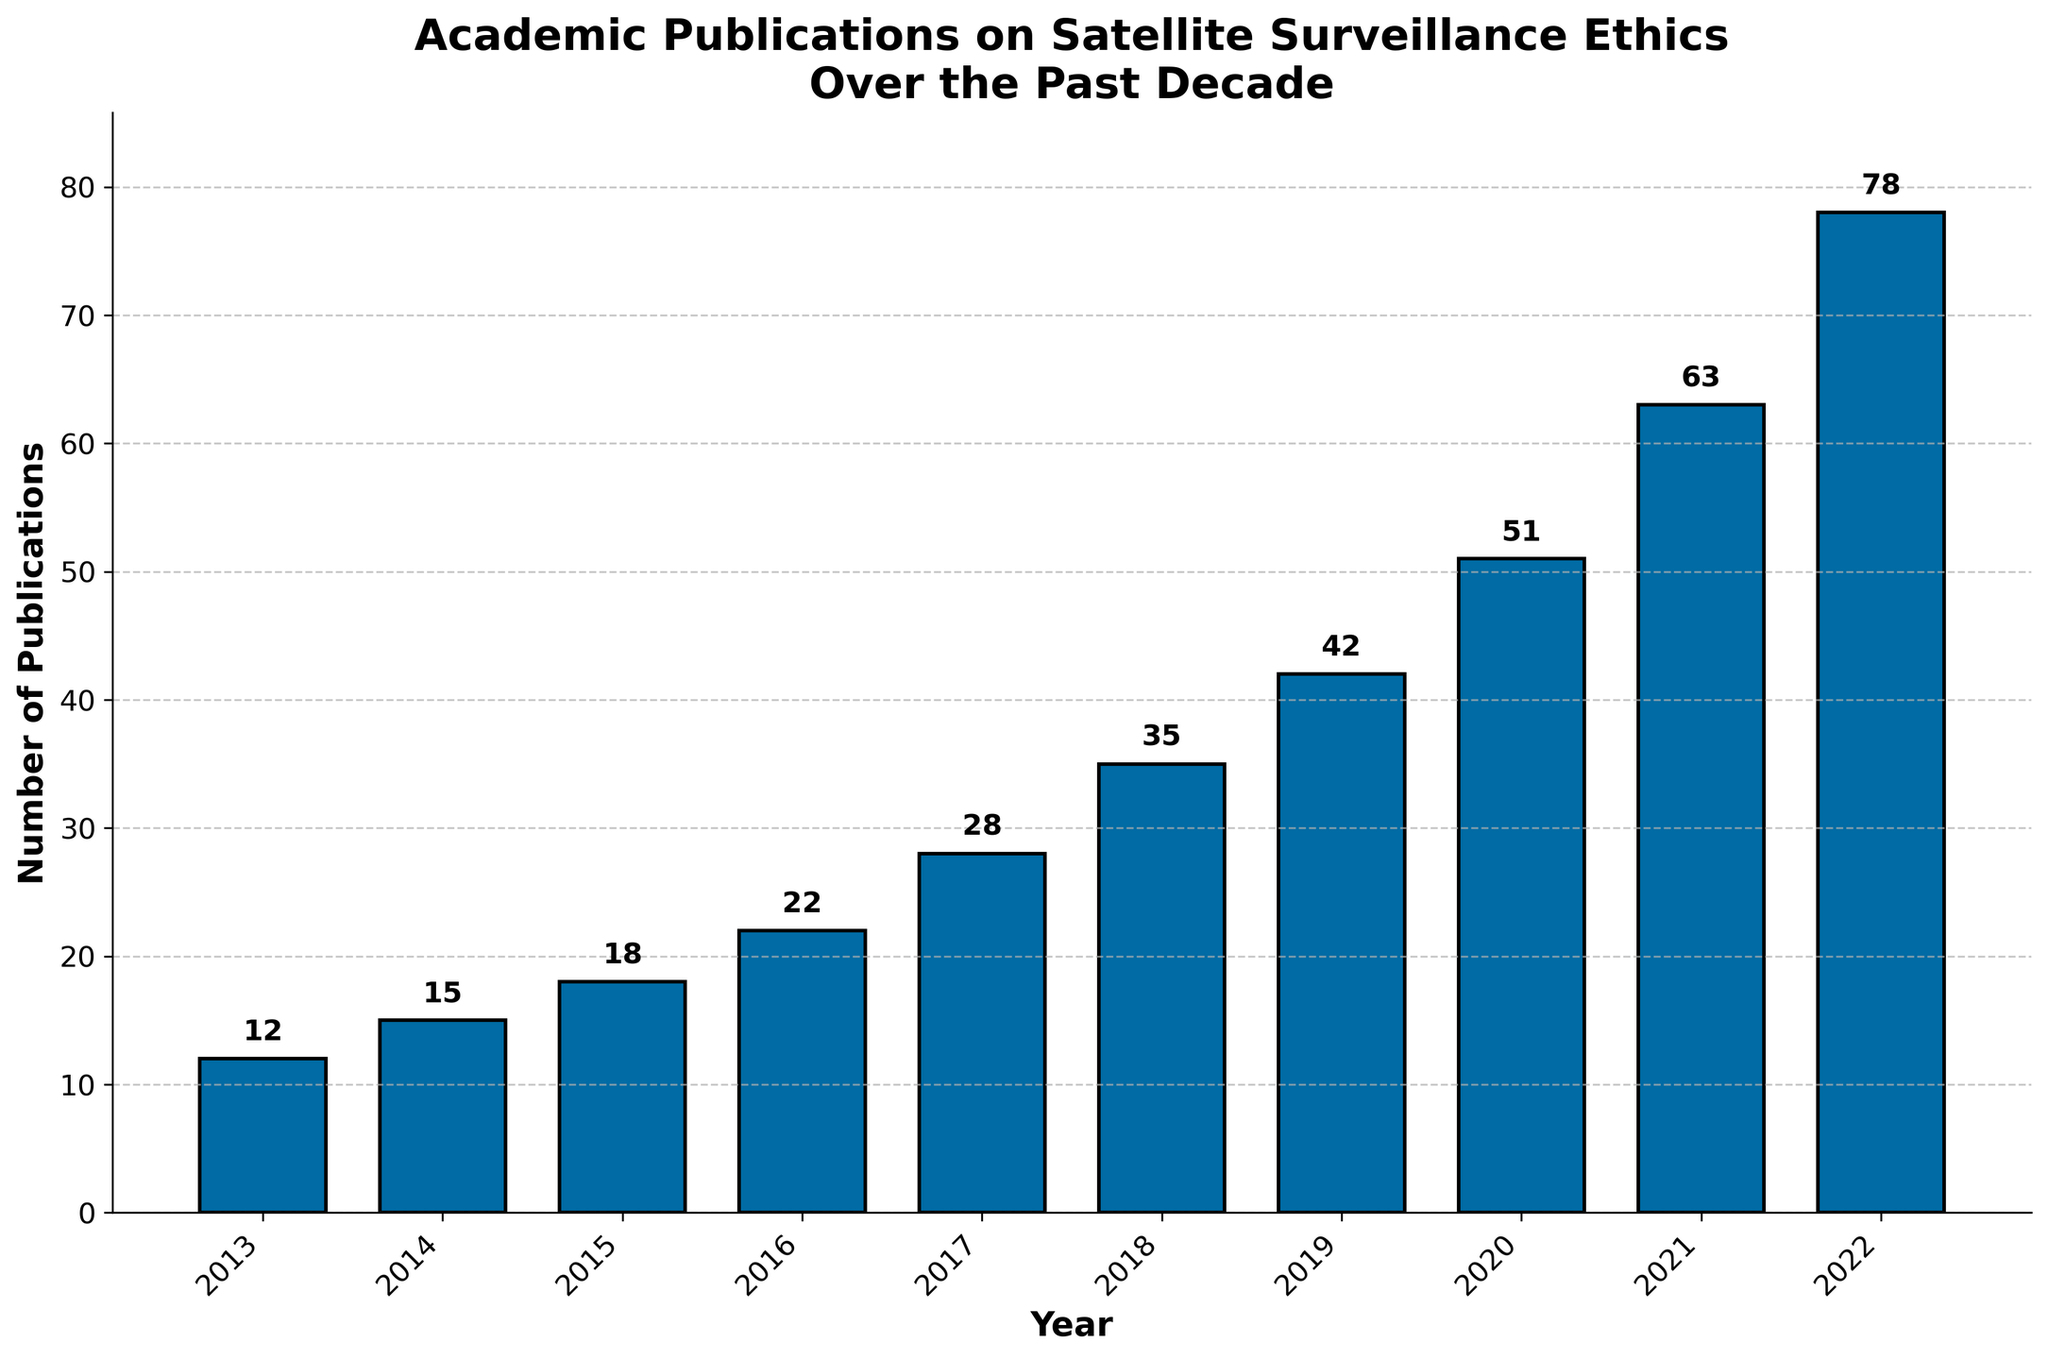What's the title of the figure? The title is typically located at the top of the figure. In this figure, it clearly states the focus area in bold.
Answer: Academic Publications on Satellite Surveillance Ethics Over the Past Decade What is the label of the x-axis? The x-axis label is found below the horizontal axis, describing what the axis represents. Here, it is explicitly defined in bold text.
Answer: Year Which year has the highest number of publications? By examining the heights of the bars corresponding to each year, the tallest bar represents the year with the highest number of publications.
Answer: 2022 How many publications were there in 2018? Look at the height of the bar labeled 2018 and read the number on top of it or the y-axis value it reaches.
Answer: 35 What's the difference in the number of publications between 2015 and 2017? Identify the number of publications for both years and subtract the 2015 value from the 2017 value. (2017: 28, 2015: 18, Difference: 28 - 18)
Answer: 10 What's the average number of publications per year over the past decade? Add the total number of publications for all years and divide by the number of years (10). Sum of publications = 364, Average = 364 / 10
Answer: 36.4 How has the number of publications changed from 2013 to 2022? Compare the lowest and highest values over these years and note the trend in the growing height of bars.
Answer: Increased Which two consecutive years show the greatest increase in publications? Calculate the difference in publications between each pair of consecutive years and identify the pair with the largest difference. (2021 to 2022: 78 - 63 = 15, which is the largest)
Answer: 2021 and 2022 What's the total number of publications from 2013 to 2018? Add the number of publications for each year from 2013 to 2018. (12 + 15 + 18 + 22 + 28 + 35)
Answer: 130 